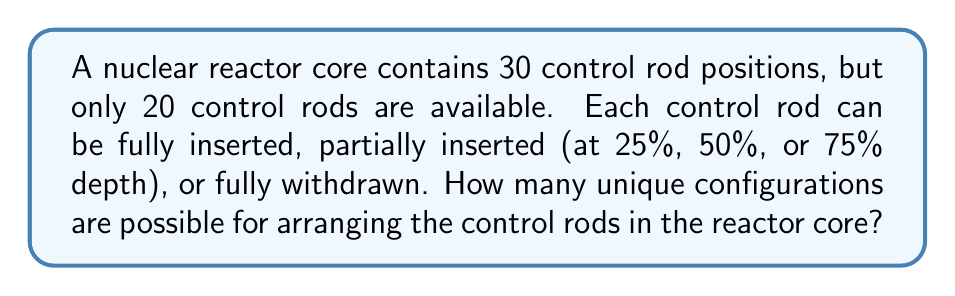Provide a solution to this math problem. Let's approach this problem step-by-step:

1) First, we need to choose which 20 out of the 30 positions will contain control rods. This is a combination problem:

   $$\binom{30}{20} = \frac{30!}{20!(30-20)!} = \frac{30!}{20!10!}$$

2) For each of these 20 positions, we have 5 options for the control rod state:
   - Fully withdrawn
   - 25% inserted
   - 50% inserted
   - 75% inserted
   - Fully inserted

3) This means for each of our chosen combinations, we have 5 choices for each of the 20 positions. This is a multiplication principle problem:

   $$5^{20}$$

4) By the multiplication principle, we multiply these two factors together to get our total number of configurations:

   $$\text{Total configurations} = \binom{30}{20} \times 5^{20}$$

5) Let's calculate this:
   
   $$\binom{30}{20} = 30,045,015$$
   
   $$5^{20} = 95,367,431,640,625$$

   $$30,045,015 \times 95,367,431,640,625 = 2,865,130,087,049,700,000,000,000$$

Therefore, there are approximately $2.87 \times 10^{24}$ unique configurations.
Answer: $2,865,130,087,049,700,000,000,000$ or approximately $2.87 \times 10^{24}$ unique configurations 